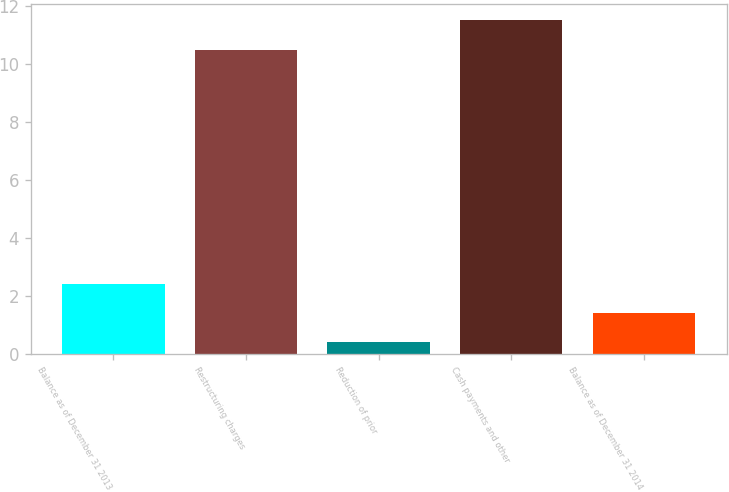Convert chart. <chart><loc_0><loc_0><loc_500><loc_500><bar_chart><fcel>Balance as of December 31 2013<fcel>Restructuring charges<fcel>Reduction of prior<fcel>Cash payments and other<fcel>Balance as of December 31 2014<nl><fcel>2.42<fcel>10.5<fcel>0.4<fcel>11.51<fcel>1.41<nl></chart> 